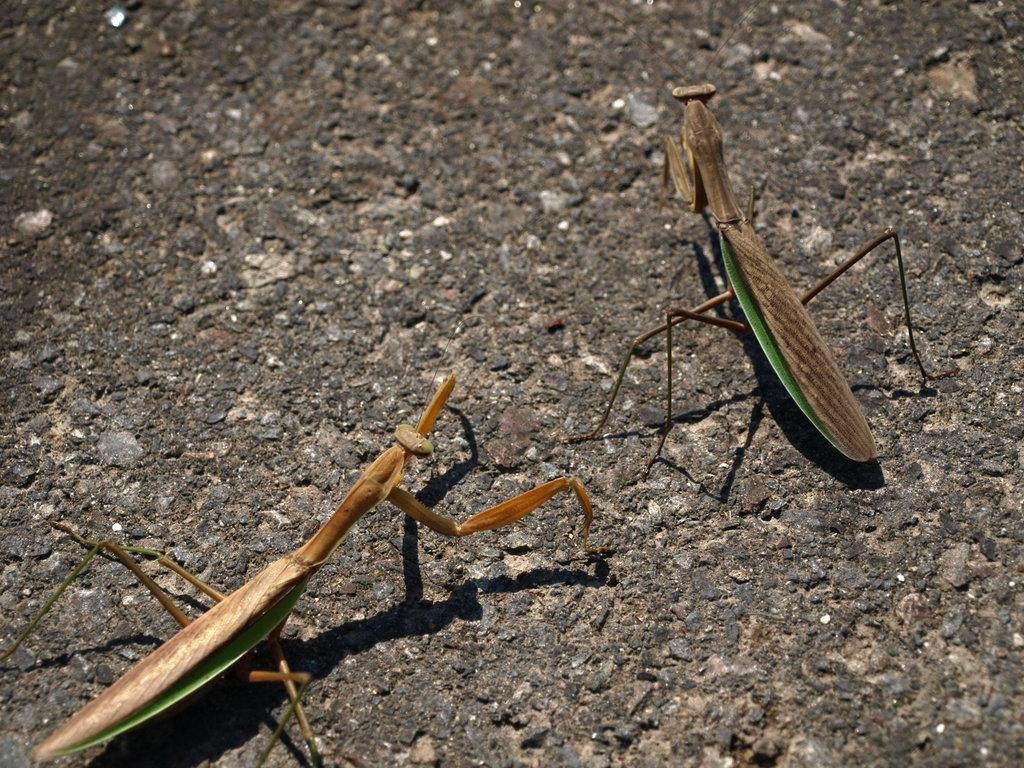How many insects are present in the image? There are 2 insects in the image. What colors can be seen on the insects? The insects are brown and green in color. What is the background color in the image? The insects are on a black color surface. Who is the actor representing the insects in the image? There is no actor present in the image, as it is a photograph of real insects. 